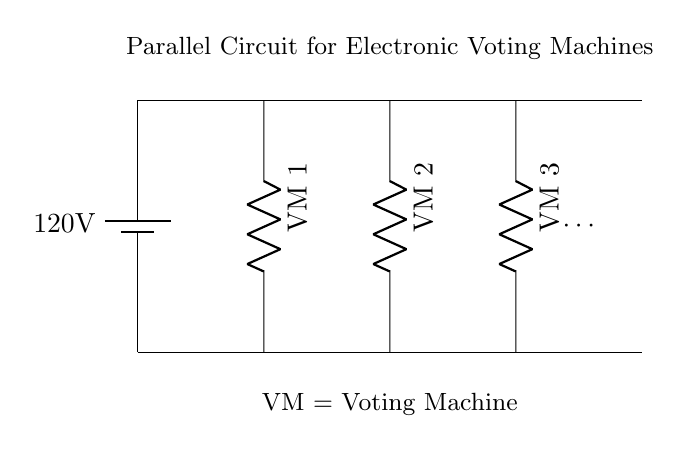What is the voltage of this circuit? The voltage in the circuit is 120 volts, which is indicated by the battery symbol at the top left.
Answer: 120 volts What type of circuit is represented here? This circuit is a parallel circuit, as all components (voting machines) are connected across the same two nodes, allowing each one to operate independently with the same voltage.
Answer: Parallel How many voting machines are depicted in this circuit? There are three voting machines explicitly shown in the diagram, labeled as VM 1, VM 2, and VM 3, with an ellipsis indicating the possibility of more.
Answer: Three What does VM stand for in this circuit? VM stands for Voting Machine, as denoted in the labels on the right side of the circuit diagram.
Answer: Voting Machine If one voting machine fails, what happens to the others? If one voting machine fails, the others continue to function normally since they are connected in parallel and each has its own separate path for current.
Answer: They continue to function What is the purpose of the ellipsis in the diagram? The ellipsis indicates that there can be additional voting machines connected to the circuit, suggesting scalability for more machines beyond what is drawn.
Answer: Additional machines 